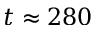<formula> <loc_0><loc_0><loc_500><loc_500>t \approx 2 8 0</formula> 